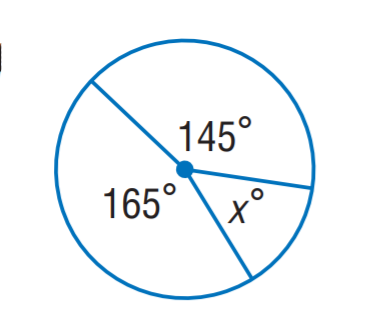Question: Find x.
Choices:
A. 35
B. 40
C. 50
D. 60
Answer with the letter. Answer: C 